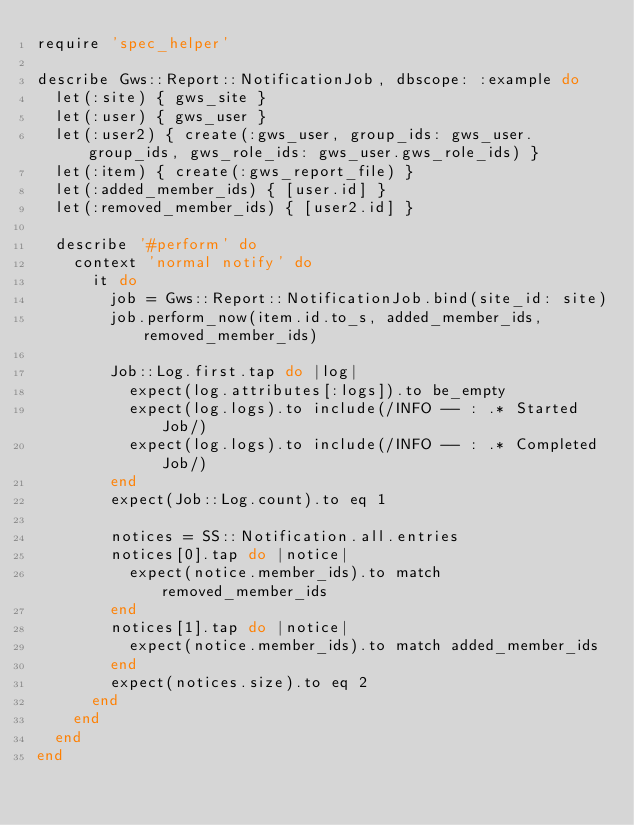<code> <loc_0><loc_0><loc_500><loc_500><_Ruby_>require 'spec_helper'

describe Gws::Report::NotificationJob, dbscope: :example do
  let(:site) { gws_site }
  let(:user) { gws_user }
  let(:user2) { create(:gws_user, group_ids: gws_user.group_ids, gws_role_ids: gws_user.gws_role_ids) }
  let(:item) { create(:gws_report_file) }
  let(:added_member_ids) { [user.id] }
  let(:removed_member_ids) { [user2.id] }

  describe '#perform' do
    context 'normal notify' do
      it do
        job = Gws::Report::NotificationJob.bind(site_id: site)
        job.perform_now(item.id.to_s, added_member_ids, removed_member_ids)

        Job::Log.first.tap do |log|
          expect(log.attributes[:logs]).to be_empty
          expect(log.logs).to include(/INFO -- : .* Started Job/)
          expect(log.logs).to include(/INFO -- : .* Completed Job/)
        end
        expect(Job::Log.count).to eq 1

        notices = SS::Notification.all.entries
        notices[0].tap do |notice|
          expect(notice.member_ids).to match removed_member_ids
        end
        notices[1].tap do |notice|
          expect(notice.member_ids).to match added_member_ids
        end
        expect(notices.size).to eq 2
      end
    end
  end
end
</code> 